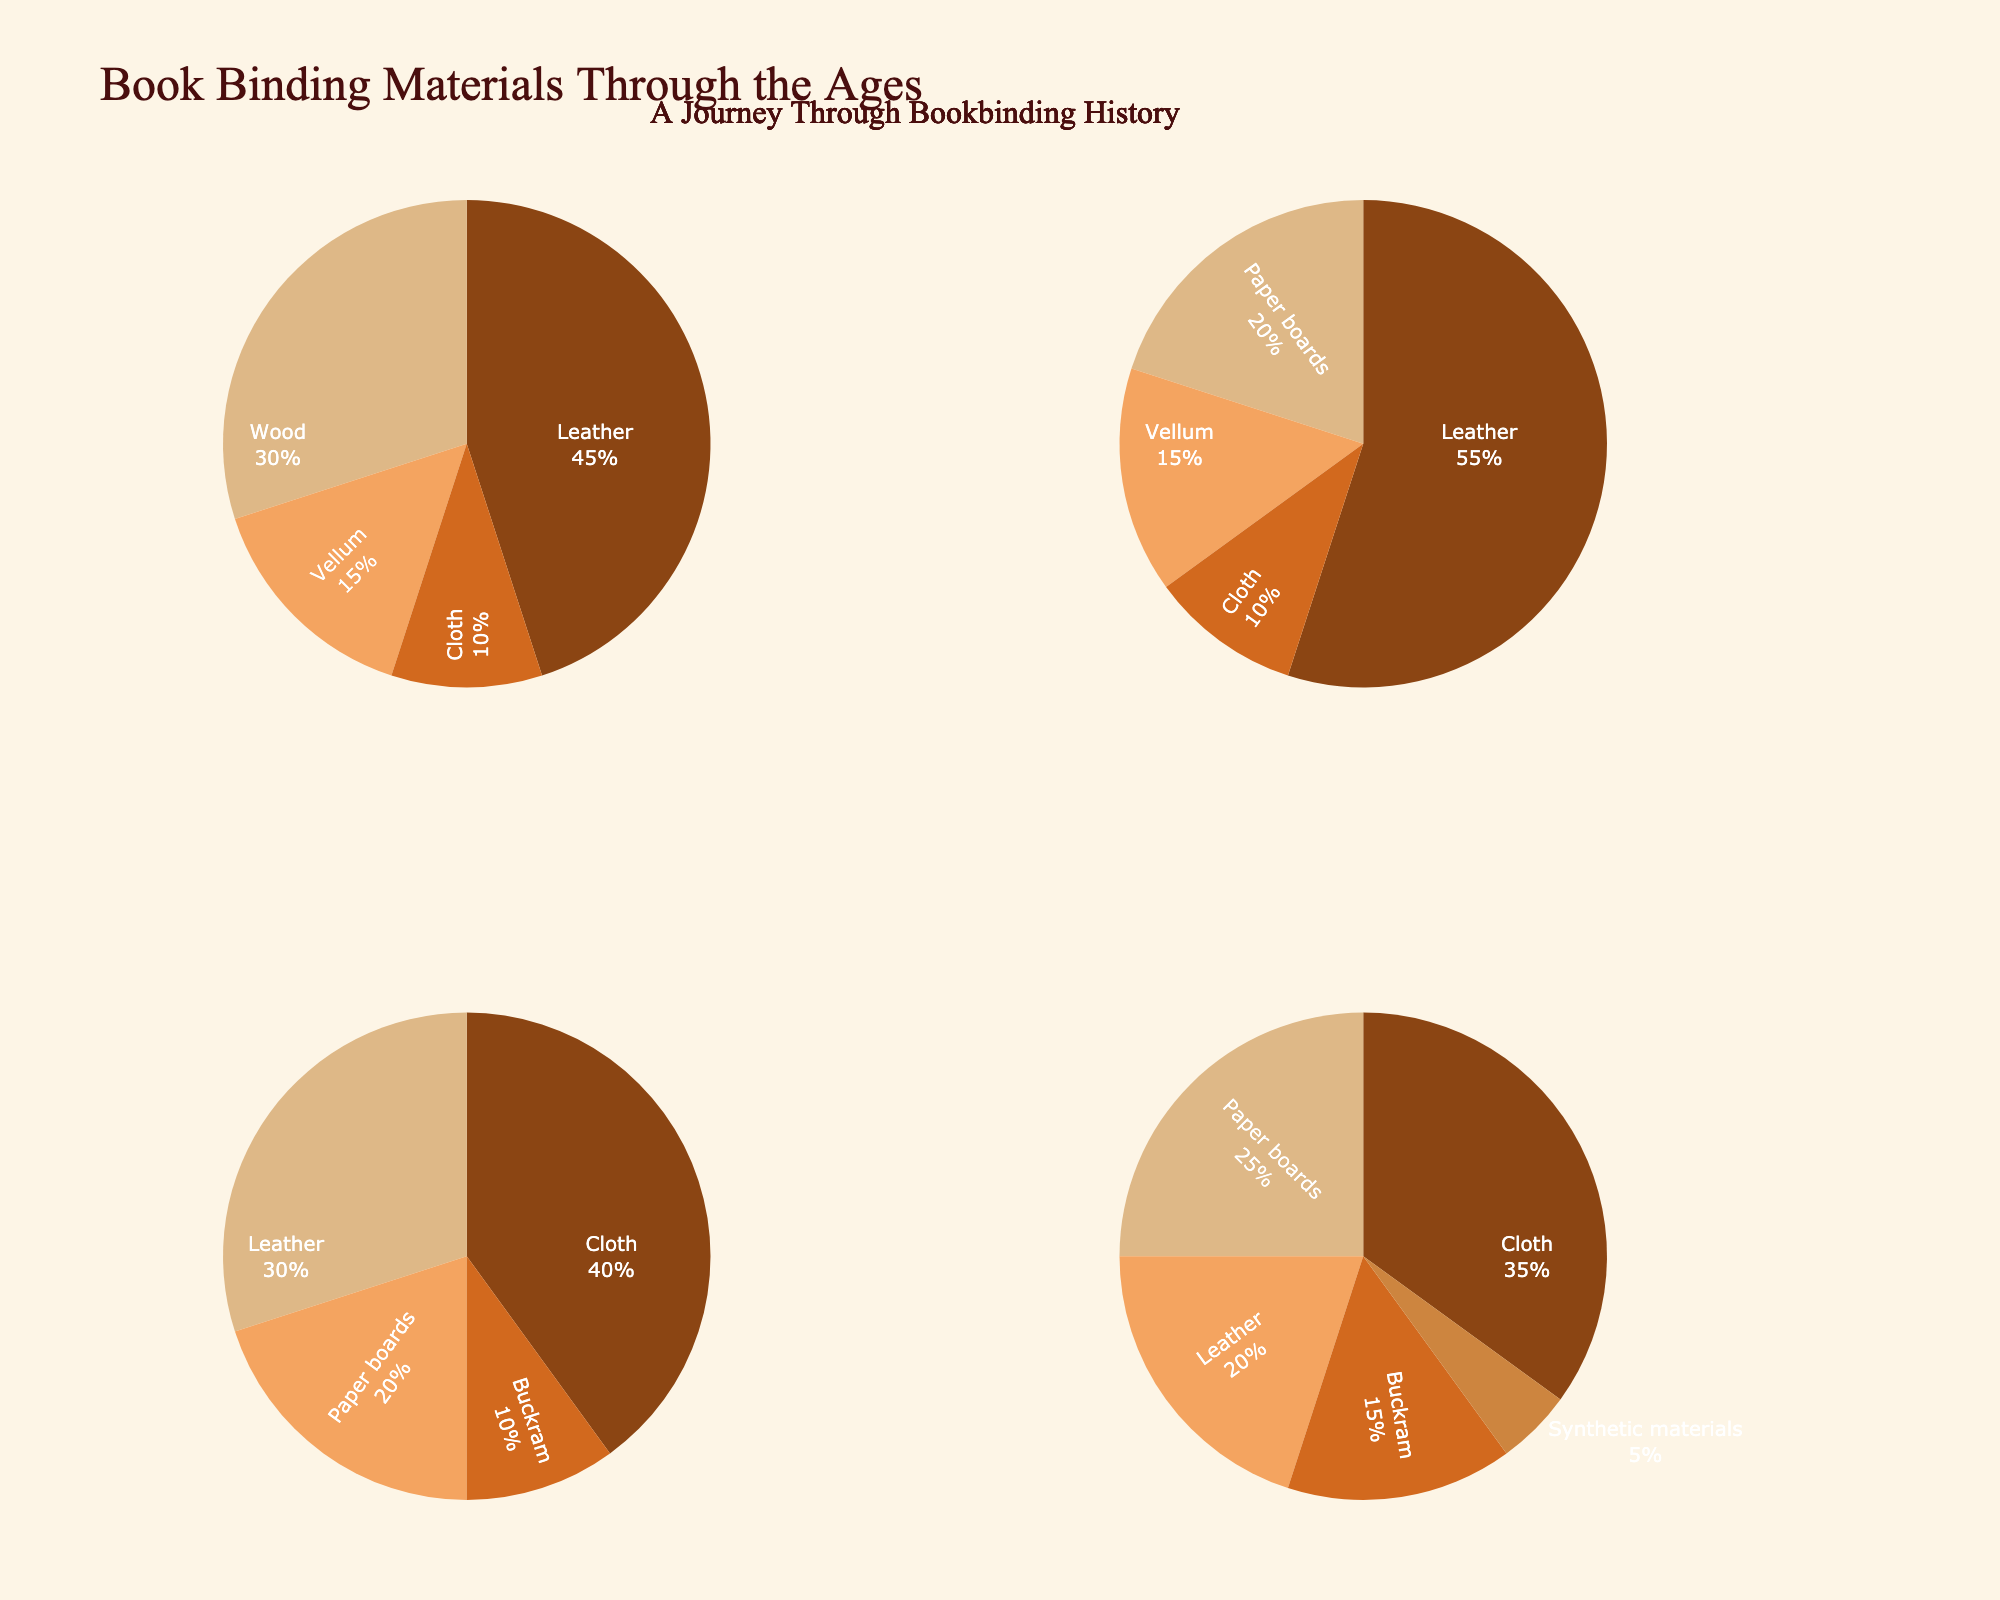what material was most commonly used in the 20th century? By looking at the pie chart section for the 20th century, we observe that "Cloth" has the largest proportion compared to other materials like Paper boards, Leather, Buckram, and Synthetic materials.
Answer: Cloth which period shows the highest proportion of leather use? Examining each pie chart, we notice that leather constitutes 55% in the 17th-18th Century, which is higher than in any other period.
Answer: 17th-18th Century compare the proportions of paper boards used in the 19th and 20th centuries. Which period has a higher proportion? By checking the sections for Paper boards in both centuries, we see that 19th Century has a 20% proportion, whereas the 20th Century has 25%. Thus, the 20th Century has a higher proportion of Paper boards.
Answer: 20th Century what are the two materials with the smallest proportions in the 15th-16th Century? Looking at the pie chart for the 15th-16th Century, the smallest sections are for "Cloth" and "Vellum", with 10% and 15%, respectively.
Answer: Cloth and Vellum how does the proportion of buckram change from the 19th to the 20th century? Observing the Buckram sections in both pie charts, we see that Buckram is 10% in the 19th Century and increases to 15% in the 20th Century. Therefore, there is a 5% increase in Buckram usage from the 19th to the 20th Century.
Answer: It increased by 5% which material used in book binding was unique to the 20th century? Observing all pie charts, only the 20th Century chart includes "Synthetic materials," which is not present in any other period.
Answer: Synthetic materials compare the total proportion of cloth usage between the 15th-16th Century and the 20th Century. Which period has more? We find the proportions of Cloth in both periods: 15th-16th Century (10%) and 20th Century (35%). By summing, we see the 20th Century has more Cloth usage.
Answer: 20th Century what materials were used in all periods displayed? By examining each pie chart, we see that Leather and Cloth are the only materials appearing in all periods.
Answer: Leather and Cloth 